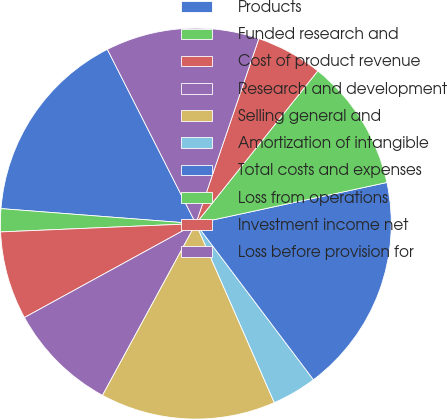<chart> <loc_0><loc_0><loc_500><loc_500><pie_chart><fcel>Products<fcel>Funded research and<fcel>Cost of product revenue<fcel>Research and development<fcel>Selling general and<fcel>Amortization of intangible<fcel>Total costs and expenses<fcel>Loss from operations<fcel>Investment income net<fcel>Loss before provision for<nl><fcel>16.3%<fcel>1.9%<fcel>7.3%<fcel>9.1%<fcel>14.5%<fcel>3.7%<fcel>18.1%<fcel>10.9%<fcel>5.5%<fcel>12.7%<nl></chart> 